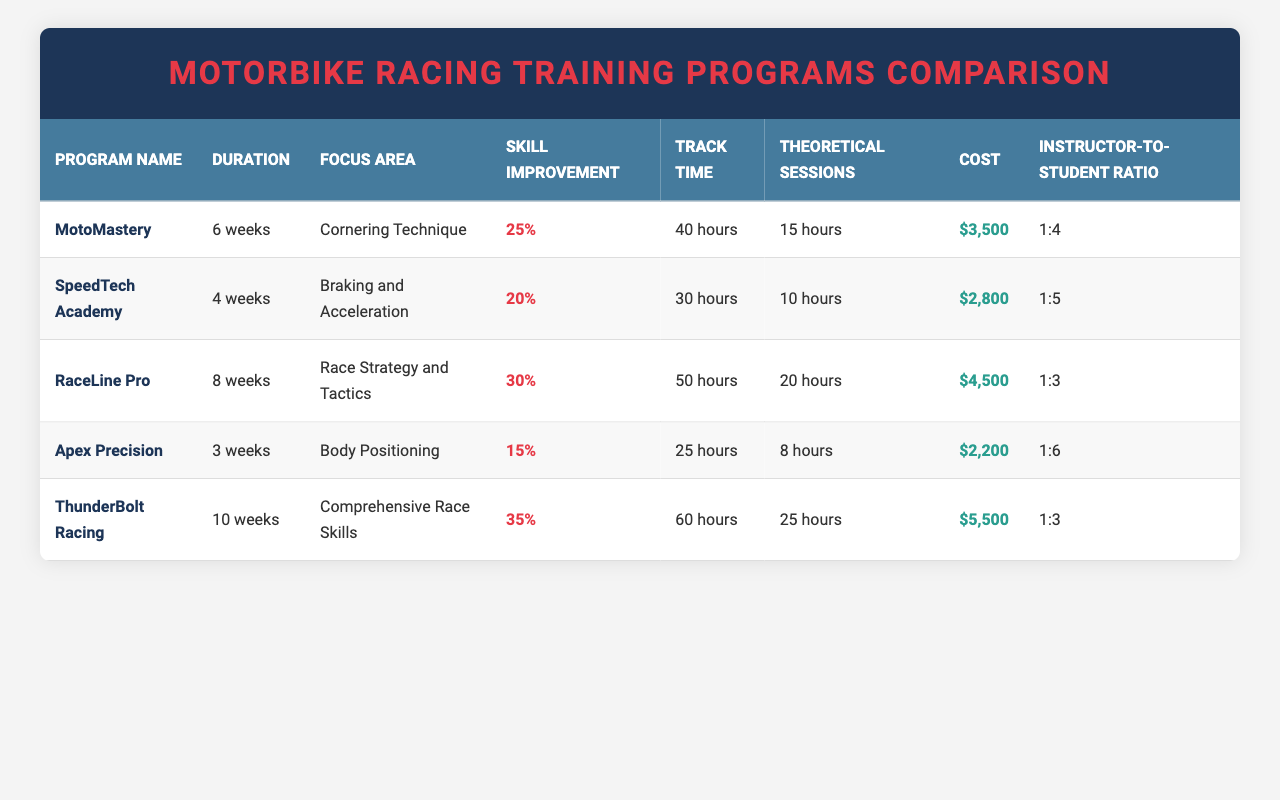What is the duration of the ThunderBolt Racing program? The table lists ThunderBolt Racing under the "Duration" column, which shows it has a duration of "10 weeks."
Answer: 10 weeks Which program focuses on race strategy and tactics? By looking at the "Focus Area" column, RaceLine Pro is the program that specifically mentions "Race Strategy and Tactics."
Answer: RaceLine Pro What is the instructor-to-student ratio for the MotoMastery program? The table indicates that the instructor-to-student ratio for MotoMastery is "1:4" in the corresponding column.
Answer: 1:4 Which program has the maximum skill improvement percentage? Comparing the "Skill Improvement" column across all programs, ThunderBolt Racing shows the highest percentage of "35%."
Answer: 35% How much more does ThunderBolt Racing cost than Apex Precision? The cost of ThunderBolt Racing is "$5,500," and the cost of Apex Precision is "$2,200." The difference is $5,500 - $2,200 = $3,300.
Answer: $3,300 Is the total track time for MotoMastery more than the total track time for SpeedTech Academy? MotoMastery has a track time of "40 hours" while SpeedTech Academy has "30 hours." Since 40 is greater than 30, the answer is yes.
Answer: Yes What is the average skill improvement of all programs? The skill improvement percentages are 25%, 20%, 30%, 15%, and 35%. We sum these: 25 + 20 + 30 + 15 + 35 = 125. Dividing by 5 gives us an average of 25%.
Answer: 25% Which program has the least amount of theoretical sessions? The table shows that Apex Precision has the least theoretical sessions at "8 hours," which is less than the other programs.
Answer: Apex Precision Which program offers the most theoretical sessions, and how many are there? Examining the "Theoretical Sessions" column, ThunderBolt Racing offers the most at "25 hours."
Answer: ThunderBolt Racing, 25 hours 